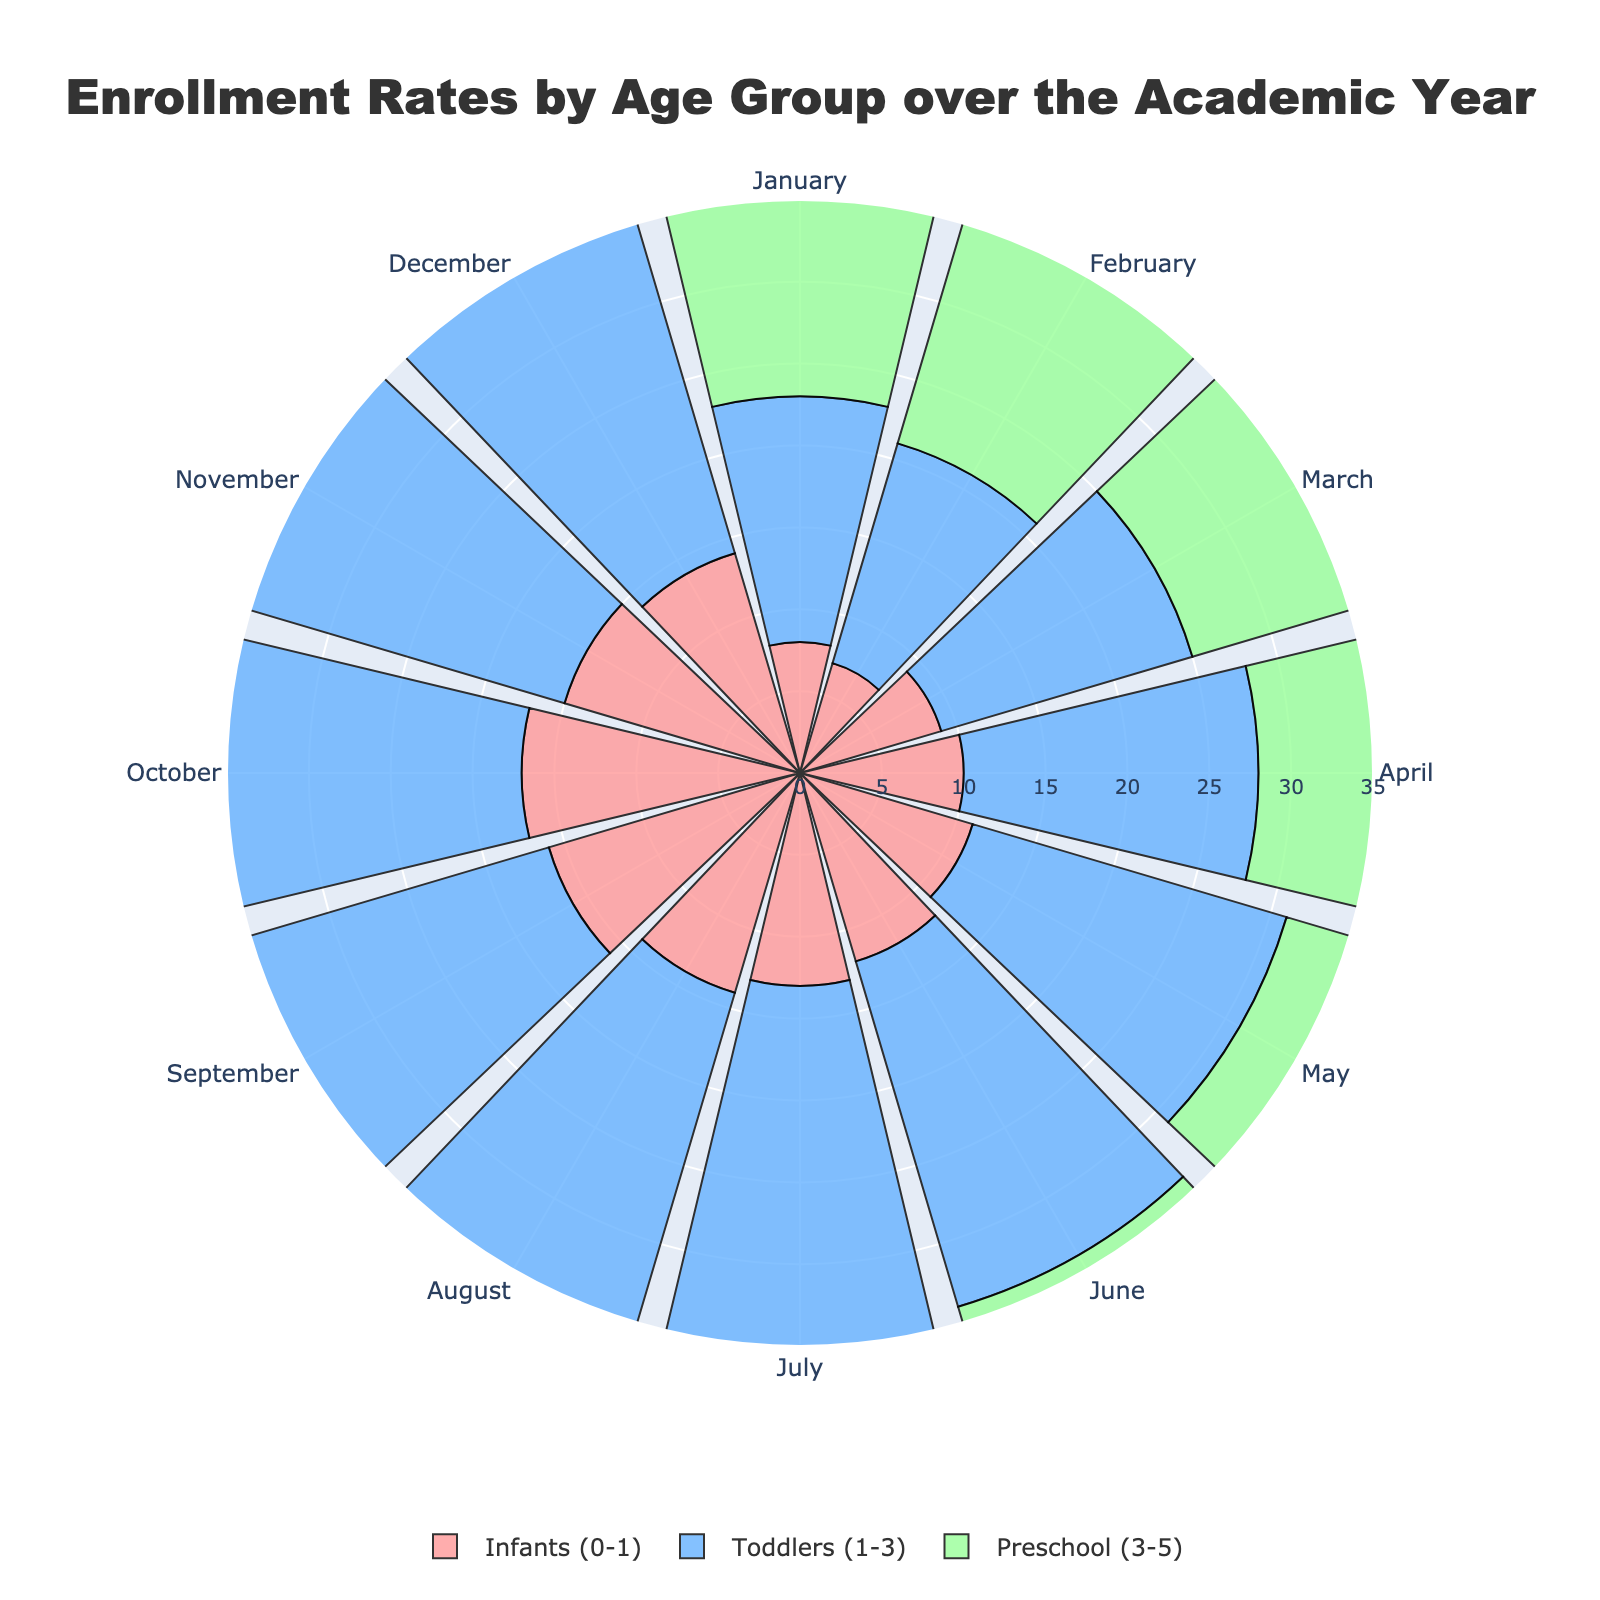what is the title of the figure? The title of the figure is displayed at the top of the plot and reads "Enrollment Rates by Age Group over the Academic Year".
Answer: Enrollment Rates by Age Group over the Academic Year How many age groups are represented in the plot? The plot contains three distinct traces, each with a different color, representing different age groups: Infants (0-1), Toddlers (1-3), and Preschool (3-5).
Answer: 3 Which age group shows the highest enrollment rate in any month? By looking at the radial distances of the bars, the Preschool (3-5) age group shows the highest enrollment rate in August, with a rate of 32.
Answer: Preschool (3-5) What's the total enrollment rate for Infants (0-1) throughout the year? Sum the enrollment rates for Infants (0-1) for all 12 months: 8 + 7 + 9 + 10 + 11 + 12 + 13 + 14 + 16 + 17 + 15 + 14 = 146.
Answer: 146 How does the enrollment rate for Toddlers (1-3) in July compare to December? The enrollment rate for Toddlers in July is 25, and for December is 24. Comparing these rates, July is greater than December by 1.
Answer: 25 > 24 Which month shows the highest discrepancy in enrollment rate between Infants (0-1) and Preschool (3-5)? By checking each month's difference between Infants (0-1) and Preschool (3-5): April (10 vs. 25), discrepancy = 15. This is the highest discrepancy across all months.
Answer: April What is the average enrollment rate for Preschool (3-5) during the summer months (June, July, August)? The enrollment rates for June, July, and August for Preschool are 29, 30, and 32. Sum these: 29 + 30 + 32 = 91. Divide by 3 to get average: 91/3 = 30.33.
Answer: 30.33 Based on the figure, during which month do all age groups see an increase in their enrollment rates compared to the previous month? Check each month for all age groups, and April shows an increase for Infants (0-1) (up from 9 to 10), Toddlers (1-3) (up from 16 to 18), and Preschool (3-5) (up from 23 to 25).
Answer: April How does the enrollment rate trend for Infants (0-1) change from January to December? Enrollment rate for Infants (0-1) generally increases from 8 in January, reaching a peak in October at 17, then slightly decreases to 14 in December.
Answer: Generally increases with a peak and a slight decrease 